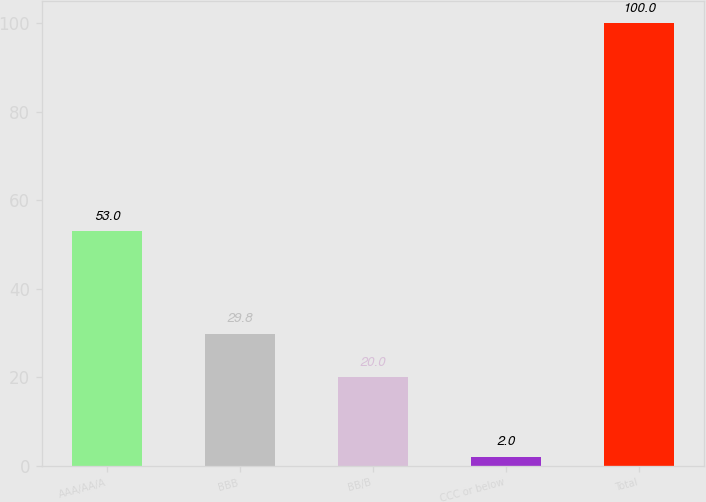Convert chart. <chart><loc_0><loc_0><loc_500><loc_500><bar_chart><fcel>AAA/AA/A<fcel>BBB<fcel>BB/B<fcel>CCC or below<fcel>Total<nl><fcel>53<fcel>29.8<fcel>20<fcel>2<fcel>100<nl></chart> 